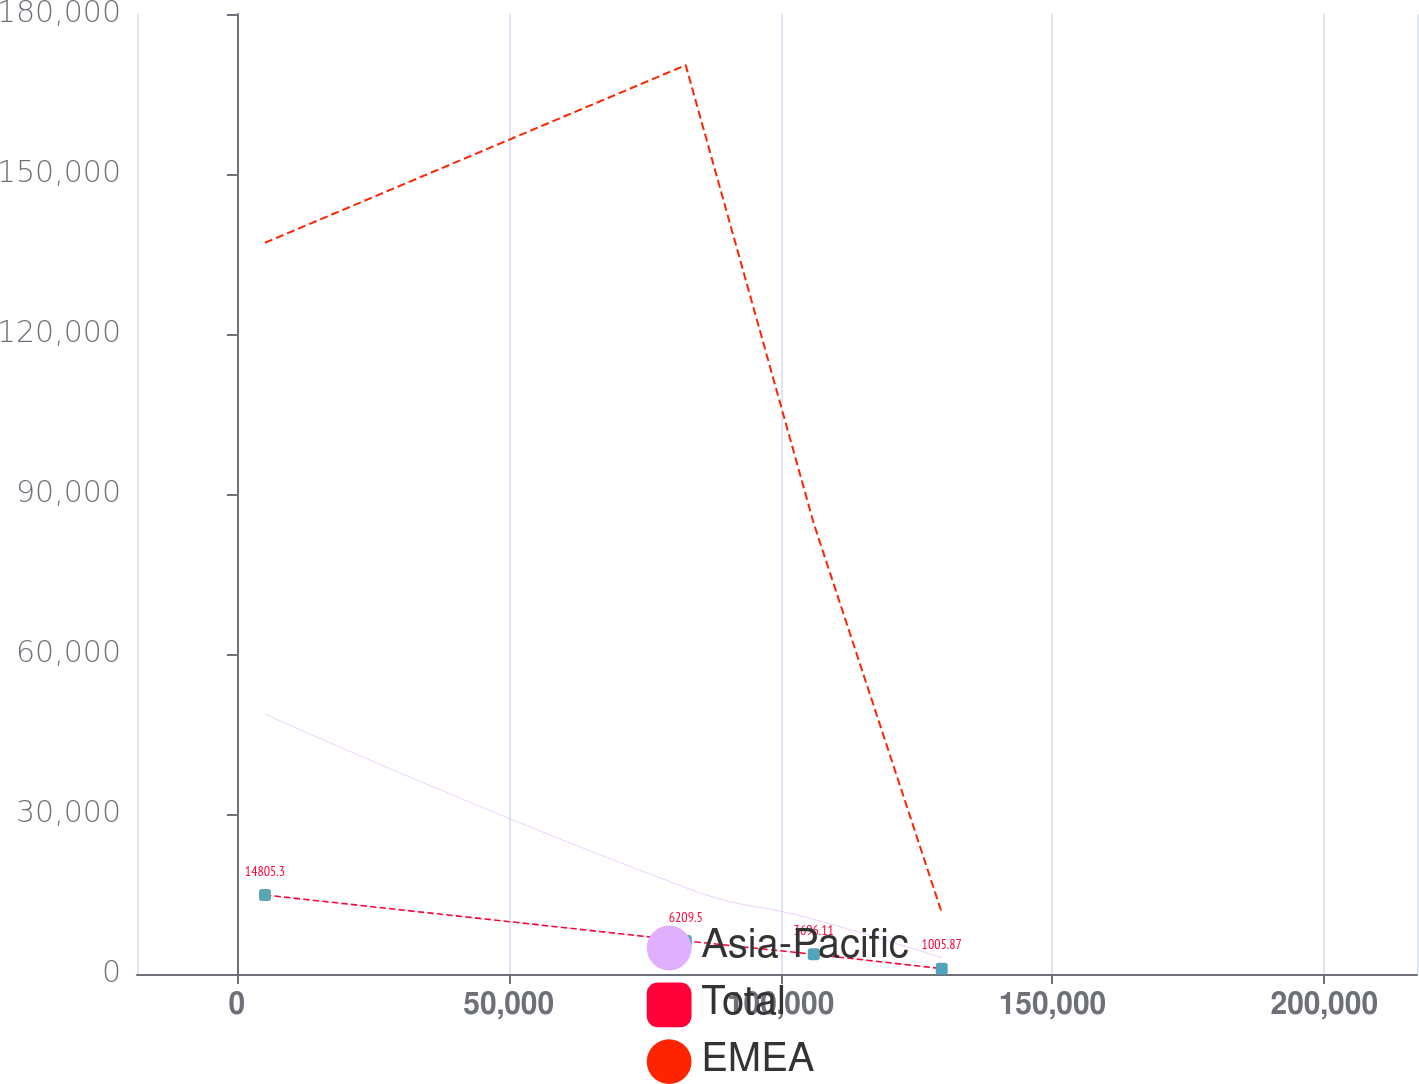Convert chart to OTSL. <chart><loc_0><loc_0><loc_500><loc_500><line_chart><ecel><fcel>Asia-Pacific<fcel>Total<fcel>EMEA<nl><fcel>5170.03<fcel>48735<fcel>14805.3<fcel>137103<nl><fcel>82553.4<fcel>16193.4<fcel>6209.5<fcel>170412<nl><fcel>106096<fcel>10258.1<fcel>3696.11<fcel>84492.2<nl><fcel>129638<fcel>3014.13<fcel>1005.87<fcel>11505.7<nl><fcel>240591<fcel>62366.9<fcel>26139.7<fcel>344596<nl></chart> 